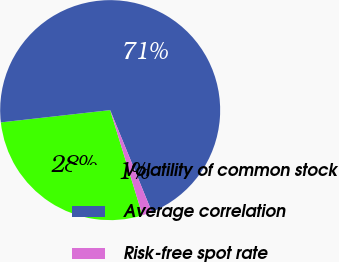Convert chart to OTSL. <chart><loc_0><loc_0><loc_500><loc_500><pie_chart><fcel>Volatility of common stock<fcel>Average correlation<fcel>Risk-free spot rate<nl><fcel>27.97%<fcel>70.59%<fcel>1.44%<nl></chart> 